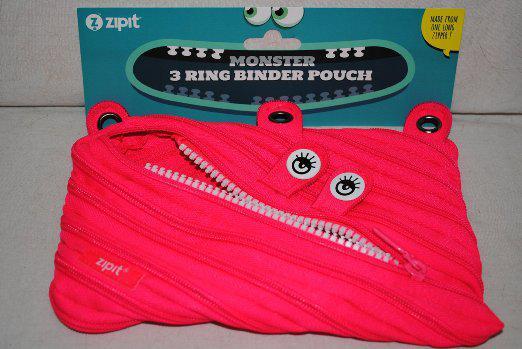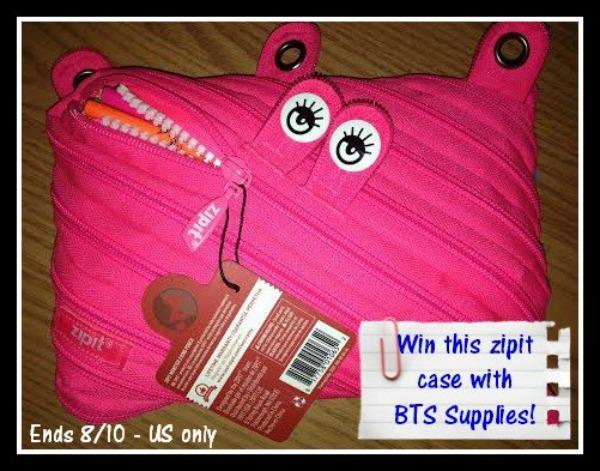The first image is the image on the left, the second image is the image on the right. For the images displayed, is the sentence "An image shows two closed fabric cases, one pink and one blue." factually correct? Answer yes or no. No. The first image is the image on the left, the second image is the image on the right. For the images shown, is this caption "Every pouch has eyes." true? Answer yes or no. Yes. 